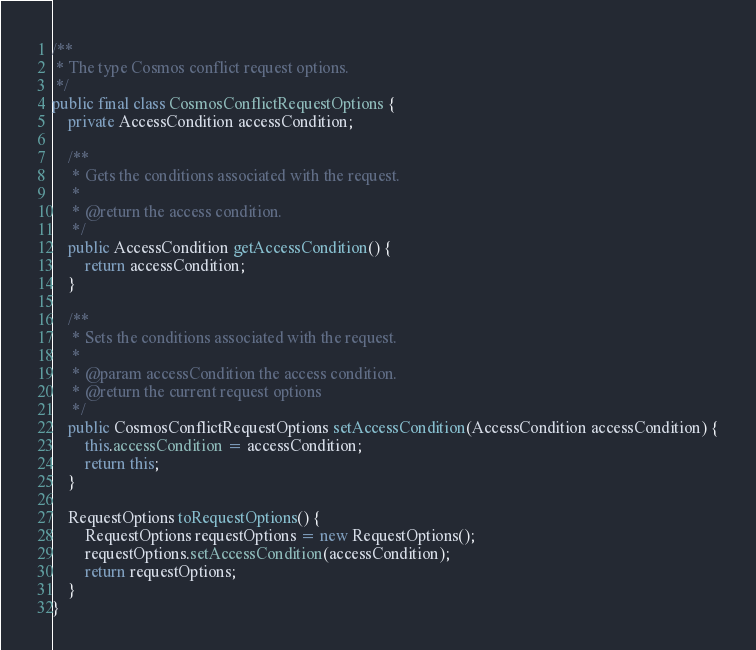Convert code to text. <code><loc_0><loc_0><loc_500><loc_500><_Java_>/**
 * The type Cosmos conflict request options.
 */
public final class CosmosConflictRequestOptions {
    private AccessCondition accessCondition;

    /**
     * Gets the conditions associated with the request.
     *
     * @return the access condition.
     */
    public AccessCondition getAccessCondition() {
        return accessCondition;
    }

    /**
     * Sets the conditions associated with the request.
     *
     * @param accessCondition the access condition.
     * @return the current request options
     */
    public CosmosConflictRequestOptions setAccessCondition(AccessCondition accessCondition) {
        this.accessCondition = accessCondition;
        return this;
    }

    RequestOptions toRequestOptions() {
        RequestOptions requestOptions = new RequestOptions();
        requestOptions.setAccessCondition(accessCondition);
        return requestOptions;
    }
}
</code> 